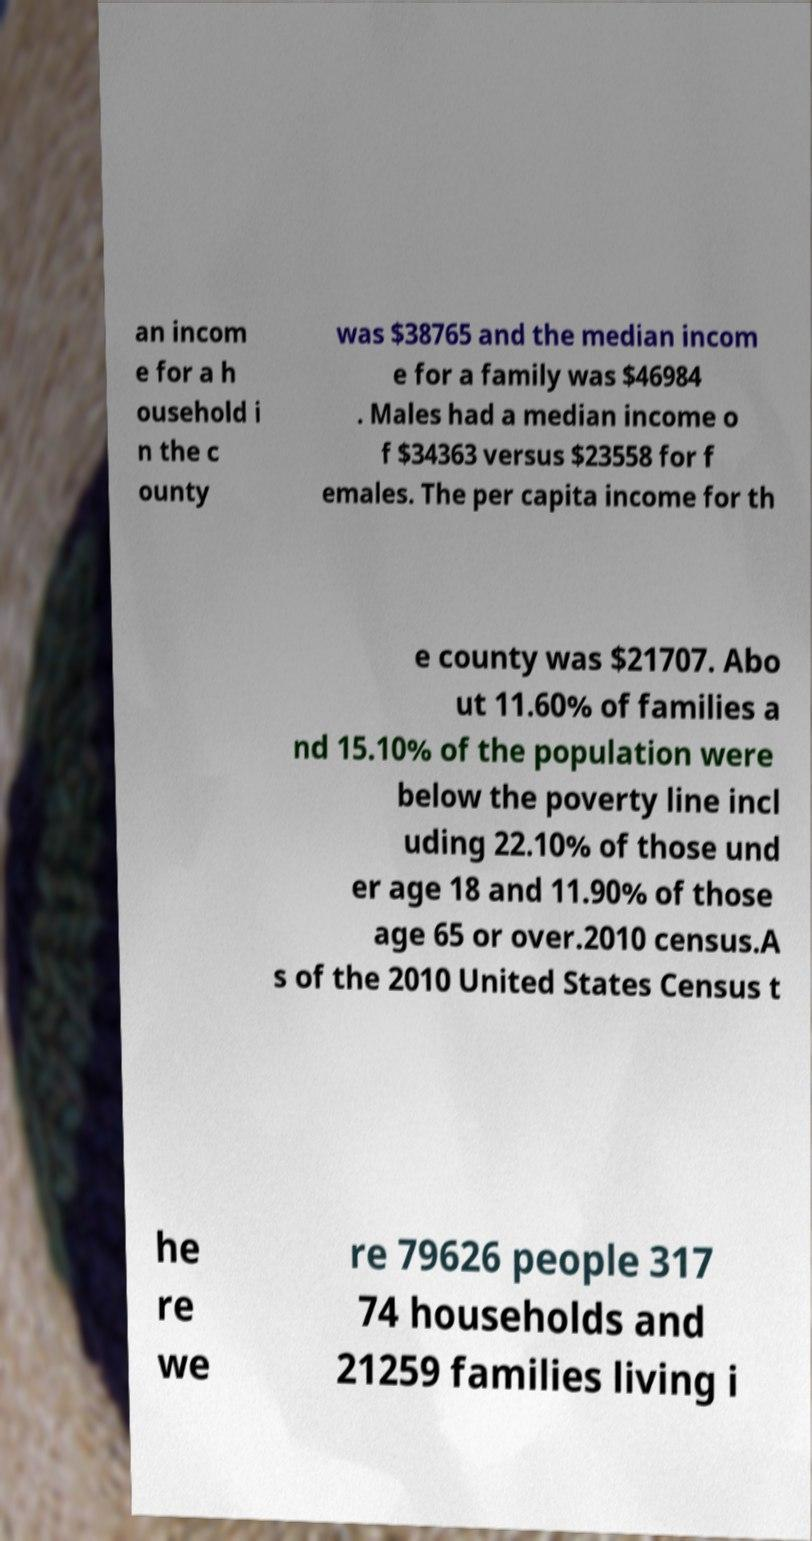There's text embedded in this image that I need extracted. Can you transcribe it verbatim? an incom e for a h ousehold i n the c ounty was $38765 and the median incom e for a family was $46984 . Males had a median income o f $34363 versus $23558 for f emales. The per capita income for th e county was $21707. Abo ut 11.60% of families a nd 15.10% of the population were below the poverty line incl uding 22.10% of those und er age 18 and 11.90% of those age 65 or over.2010 census.A s of the 2010 United States Census t he re we re 79626 people 317 74 households and 21259 families living i 